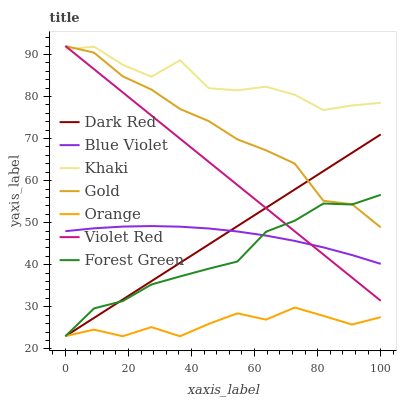Does Orange have the minimum area under the curve?
Answer yes or no. Yes. Does Khaki have the maximum area under the curve?
Answer yes or no. Yes. Does Gold have the minimum area under the curve?
Answer yes or no. No. Does Gold have the maximum area under the curve?
Answer yes or no. No. Is Dark Red the smoothest?
Answer yes or no. Yes. Is Khaki the roughest?
Answer yes or no. Yes. Is Gold the smoothest?
Answer yes or no. No. Is Gold the roughest?
Answer yes or no. No. Does Dark Red have the lowest value?
Answer yes or no. Yes. Does Gold have the lowest value?
Answer yes or no. No. Does Gold have the highest value?
Answer yes or no. Yes. Does Khaki have the highest value?
Answer yes or no. No. Is Blue Violet less than Khaki?
Answer yes or no. Yes. Is Khaki greater than Dark Red?
Answer yes or no. Yes. Does Forest Green intersect Dark Red?
Answer yes or no. Yes. Is Forest Green less than Dark Red?
Answer yes or no. No. Is Forest Green greater than Dark Red?
Answer yes or no. No. Does Blue Violet intersect Khaki?
Answer yes or no. No. 